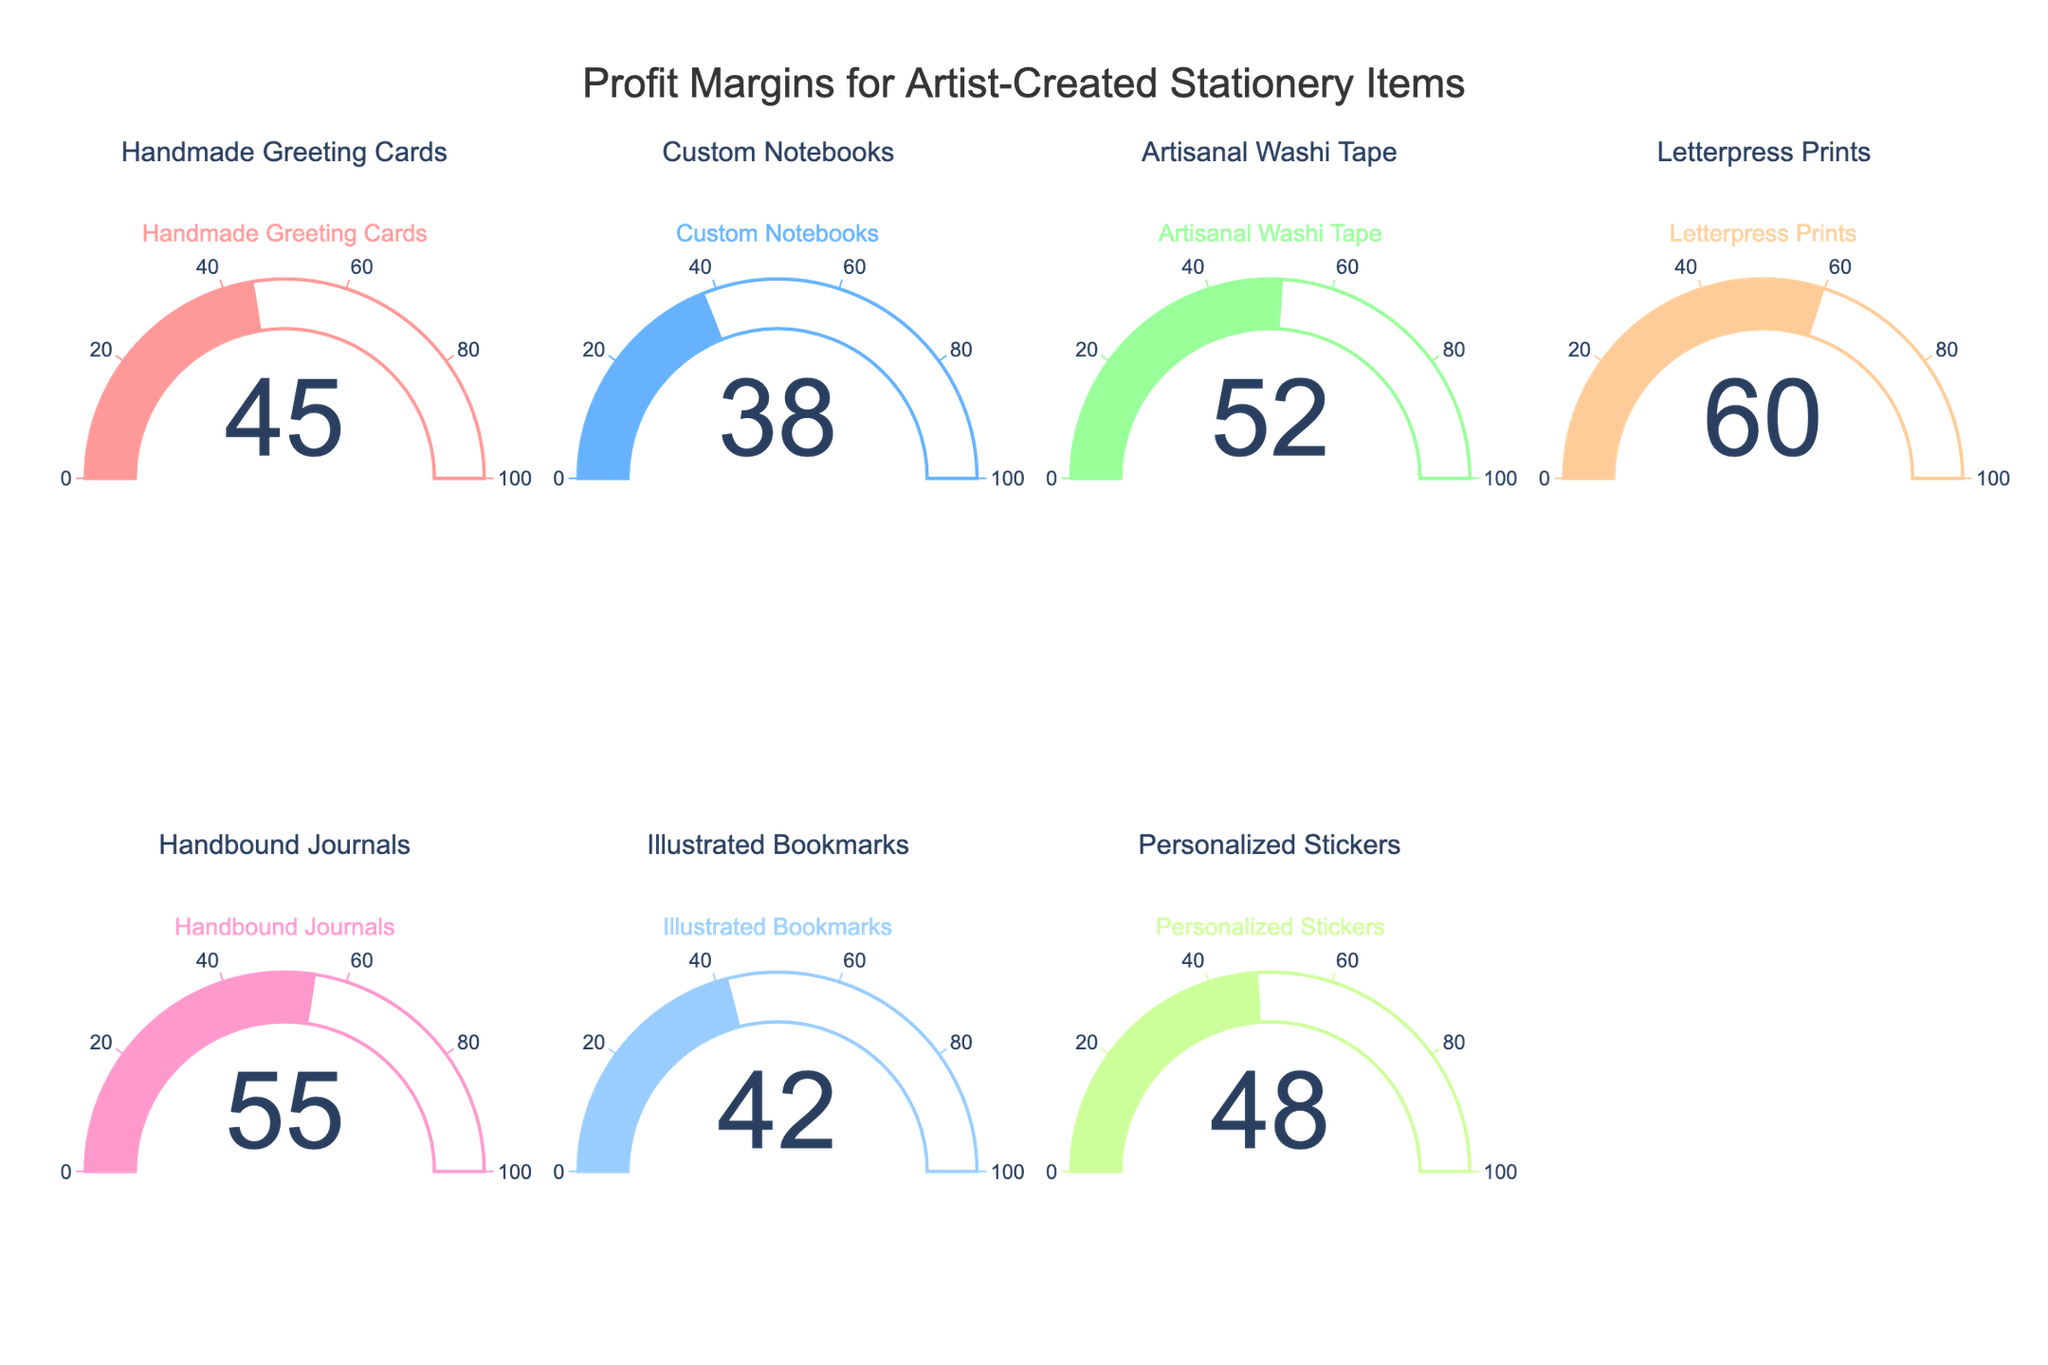Which item has the highest profit margin? The Letterpress Prints gauge shows the highest profit margin value among all categories.
Answer: Letterpress Prints Which item has the lowest profit margin? The Custom Notebooks gauge shows the lowest profit margin value among all categories.
Answer: Custom Notebooks How many items have a profit margin above 50%? The gauges for Artisanal Washi Tape, Letterpress Prints, and Handbound Journals show profit margins above 50%.
Answer: 3 What's the total profit margin of Handmade Greeting Cards and Personalized Stickers? The Handmade Greeting Cards gauge shows 45%, and the Personalized Stickers gauge shows 48%. Adding these values gives 45% + 48% = 93%.
Answer: 93% What's the average profit margin of all items? Summing all profit margins (45 + 38 + 52 + 60 + 55 + 42 + 48) and dividing by the number of items (7) gives (45 + 38 + 52 + 60 + 55 + 42 + 48)/7 = 48.57%.
Answer: 48.57% Which item has a higher profit margin, Handbound Journals or Illustrated Bookmarks? The Handbound Journals gauge shows 55%, and the Illustrated Bookmarks gauge shows 42%. 55% is higher than 42%.
Answer: Handbound Journals What's the difference in profit margin between the highest and lowest items? The highest profit margin is from Letterpress Prints at 60%, and the lowest is from Custom Notebooks at 38%. The difference is 60% - 38% = 22%.
Answer: 22% Which items have profit margins within the range of 40% to 50%? The gauges for Handmade Greeting Cards (45%), Illustrated Bookmarks (42%), and Personalized Stickers (48%) are within the 40-50% range.
Answer: Handmade Greeting Cards, Illustrated Bookmarks, Personalized Stickers 